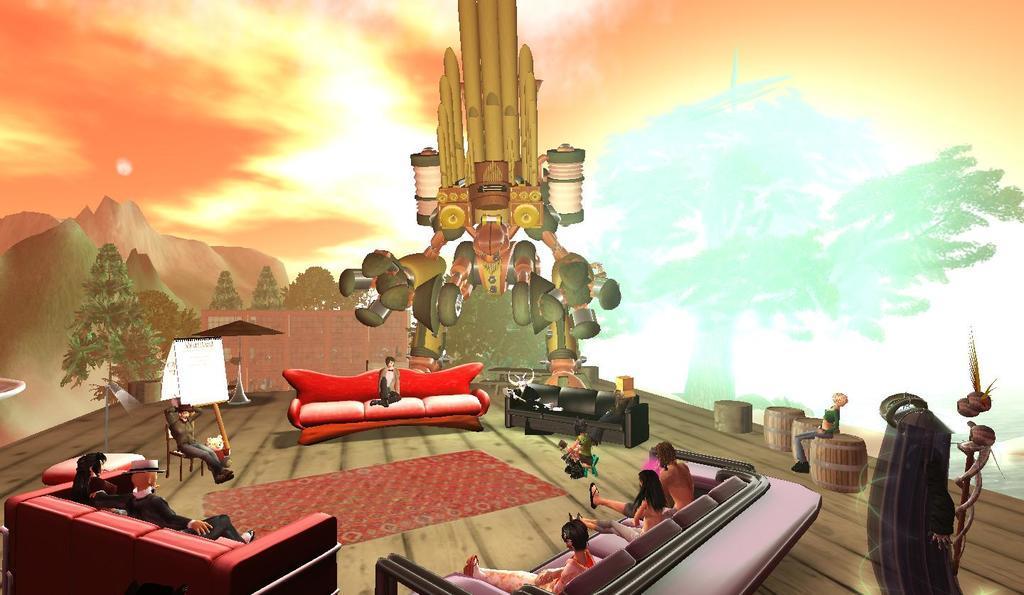Describe this image in one or two sentences. In the image there are different animations, there are depictions of people sitting on the sofas and around them there are some visual effects. 